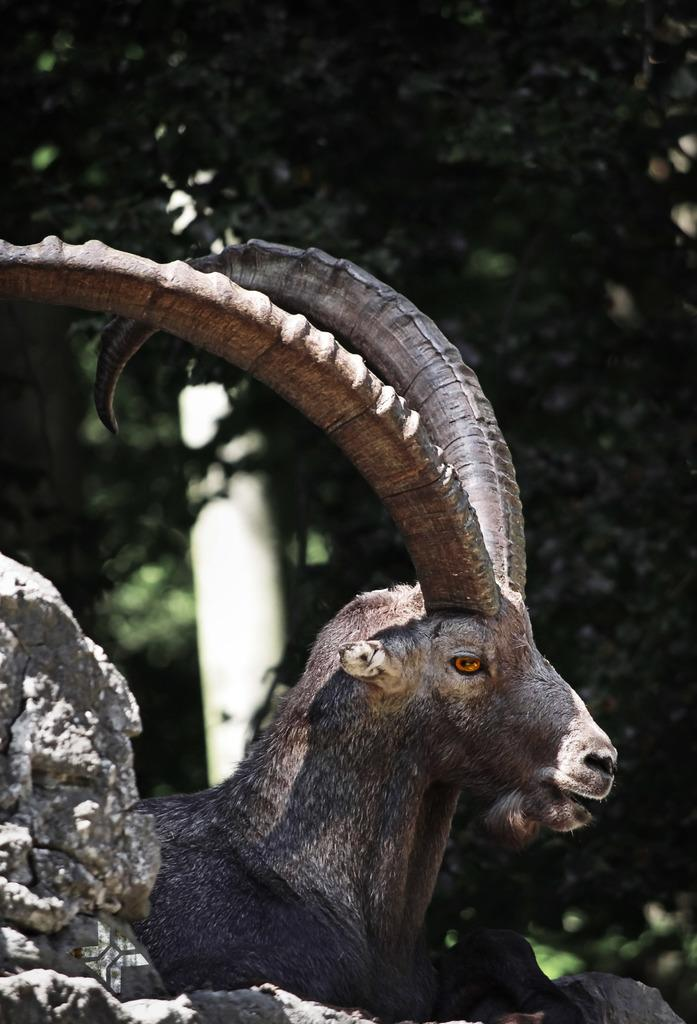What type of animal is in the image? The type of animal cannot be determined from the provided facts. What is the rock used for in the image? The purpose of the rock cannot be determined from the provided facts. What can be seen in the background of the image? There are trees in the background of the image. What is the object that looks like a pole in the image? The object that looks like a pole cannot be identified further from the provided facts. What type of cheese is being stored in the pocket in the image? There is no pocket or cheese present in the image. 